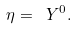Convert formula to latex. <formula><loc_0><loc_0><loc_500><loc_500>\eta = \ Y ^ { 0 } .</formula> 